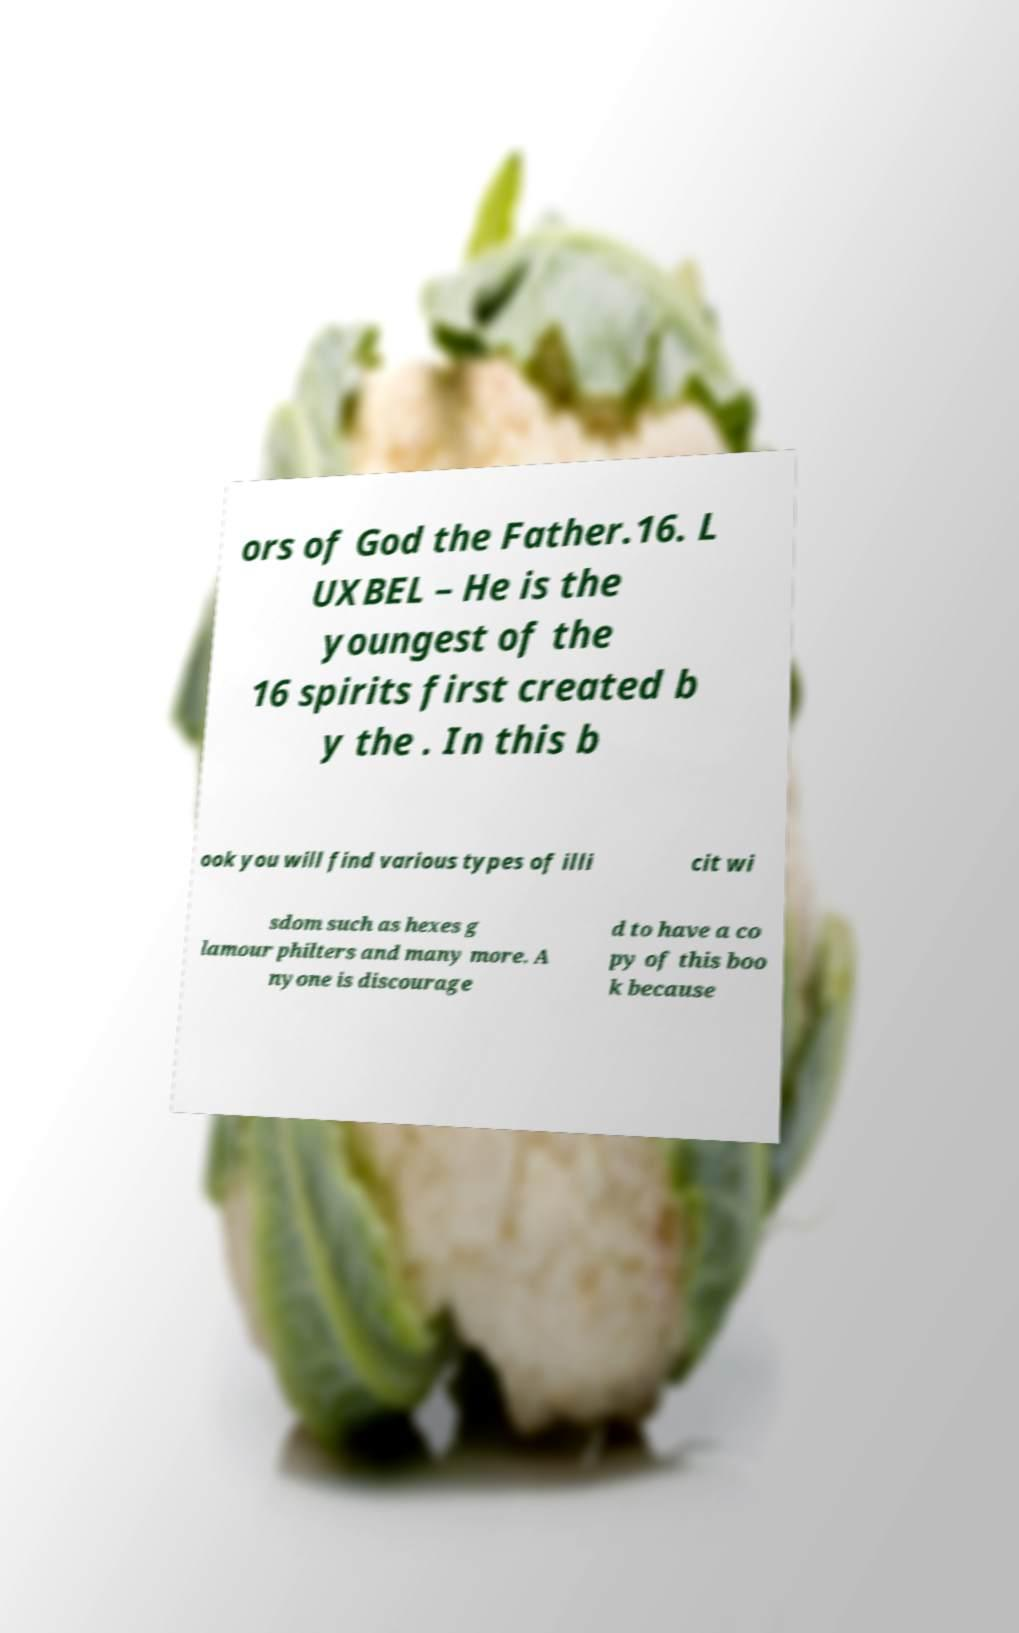Can you read and provide the text displayed in the image?This photo seems to have some interesting text. Can you extract and type it out for me? ors of God the Father.16. L UXBEL – He is the youngest of the 16 spirits first created b y the . In this b ook you will find various types of illi cit wi sdom such as hexes g lamour philters and many more. A nyone is discourage d to have a co py of this boo k because 